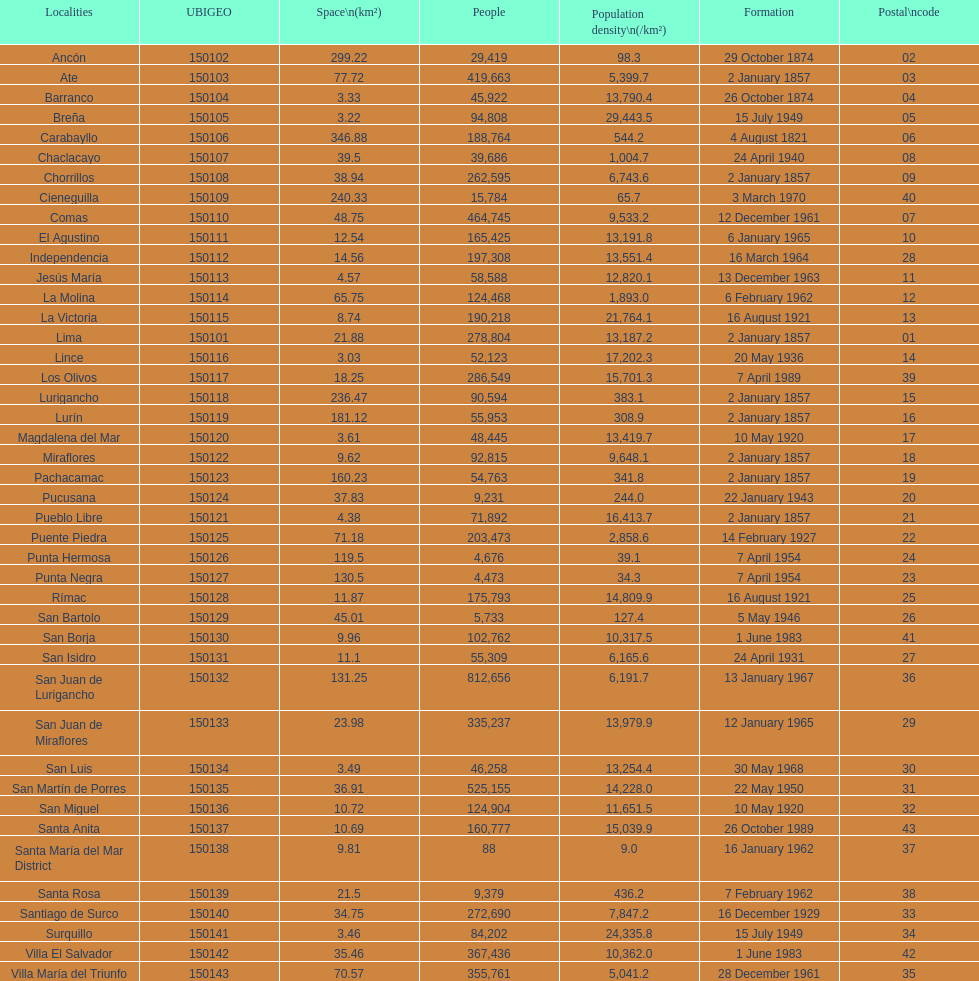What is the total number of districts created in the 1900's? 32. 